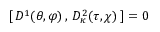Convert formula to latex. <formula><loc_0><loc_0><loc_500><loc_500>[ \, D ^ { 1 } ( \theta , \varphi ) \, , \, D _ { \kappa } ^ { 2 } ( \tau , \chi ) \, ] = 0</formula> 